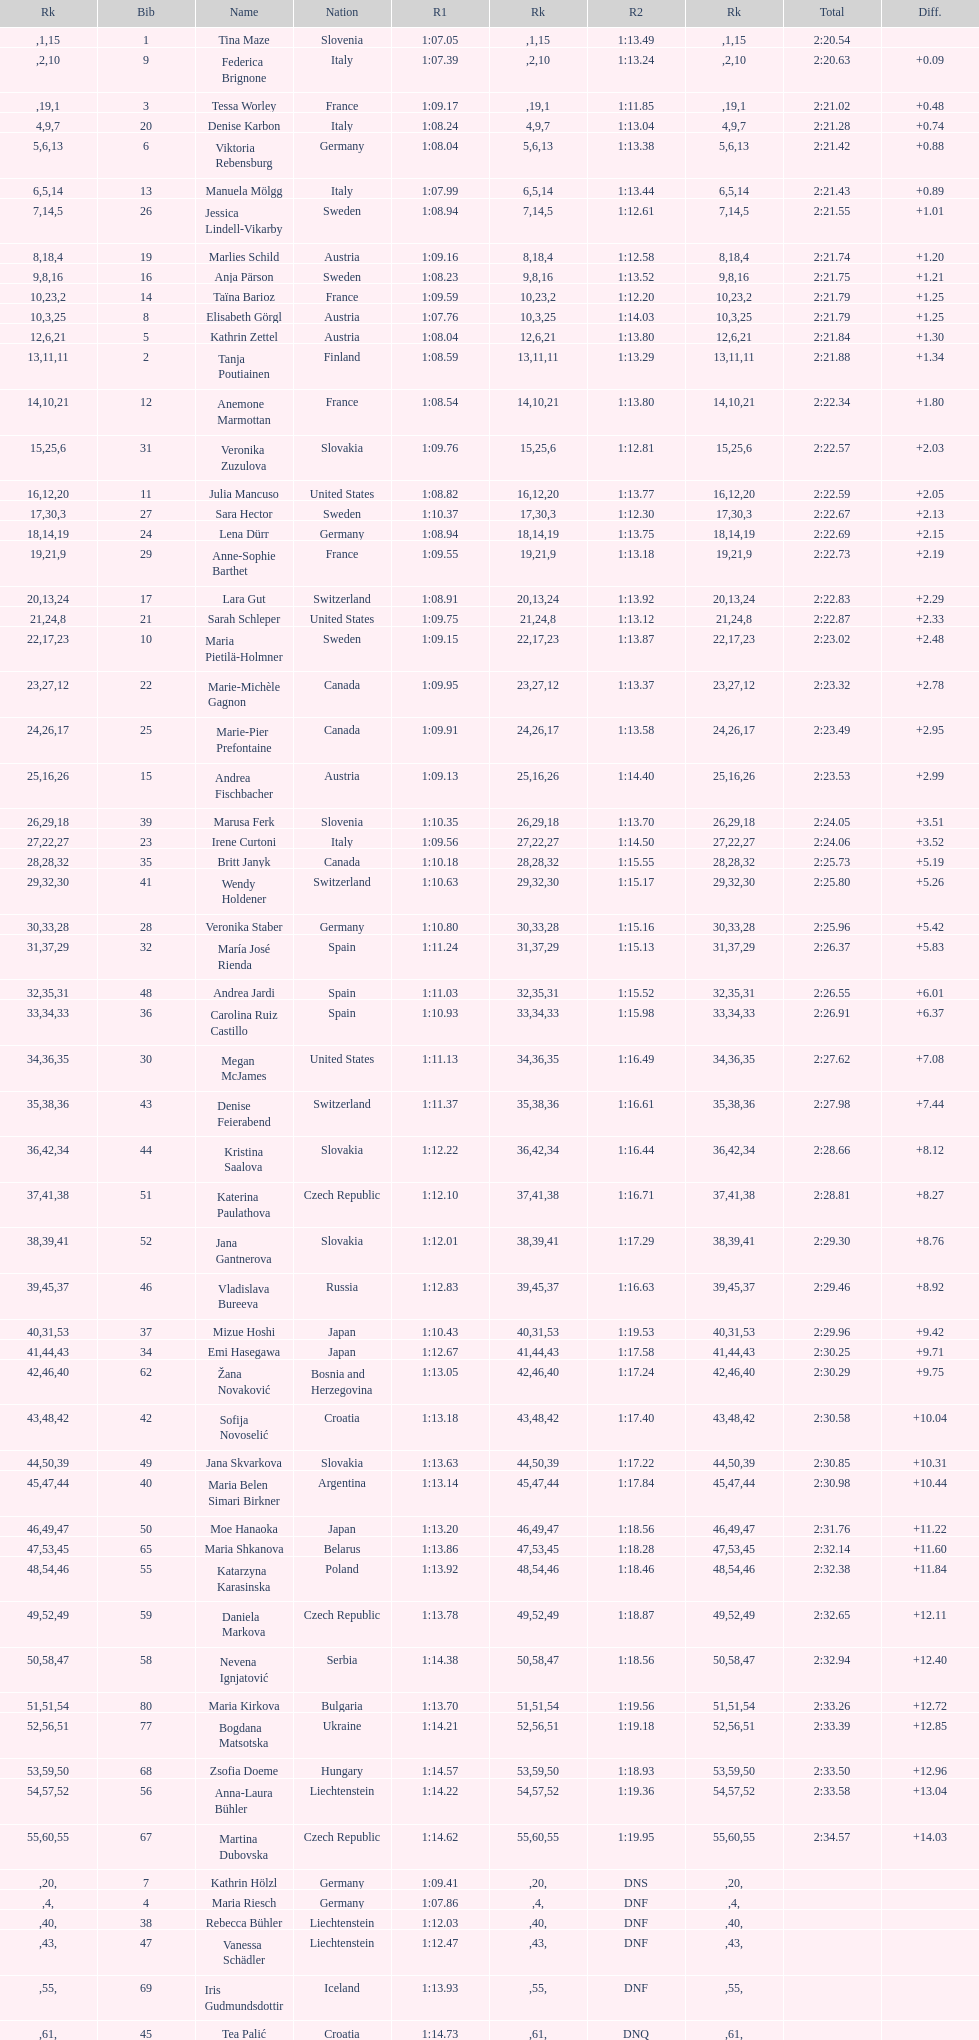How many athletes had the same rank for both run 1 and run 2? 1. 